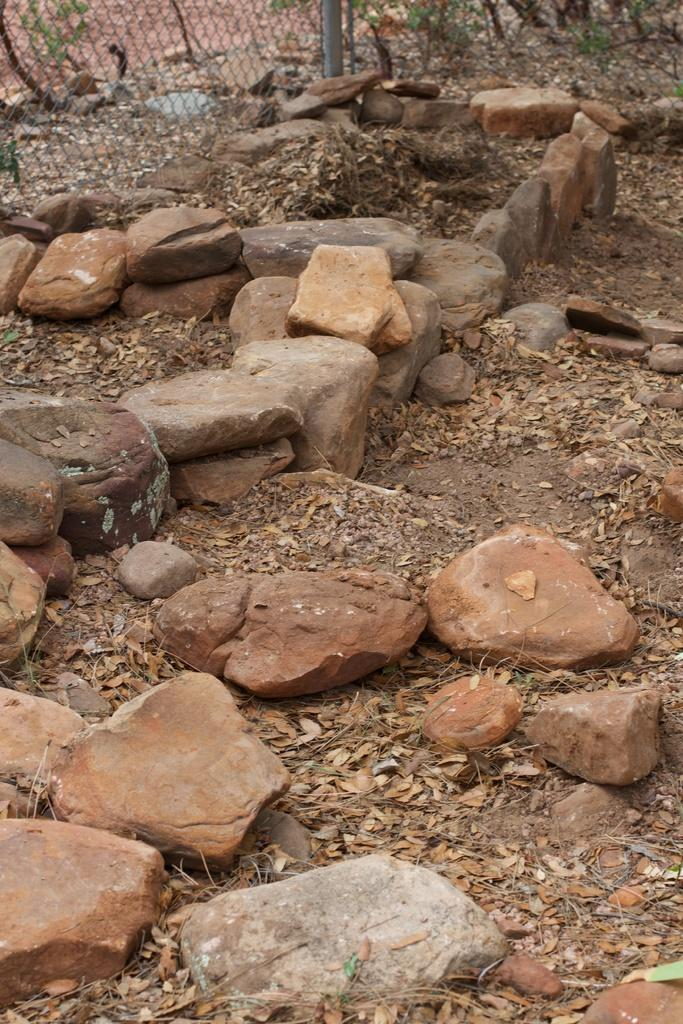What type of natural elements can be seen in the image? There are stones and dry leaves in the image. What is located at the top of the image? There are plants and fencing at the top of the image. Are there any dry leaves present near the plants at the top of the image? Yes, there are also dry leaves at the top of the image. What type of pain is the group of people experiencing in the image? There are no people present in the image, so it is not possible to determine if they are experiencing any pain. Can you tell me how many crooks are visible in the image? There are no crooks present in the image. 